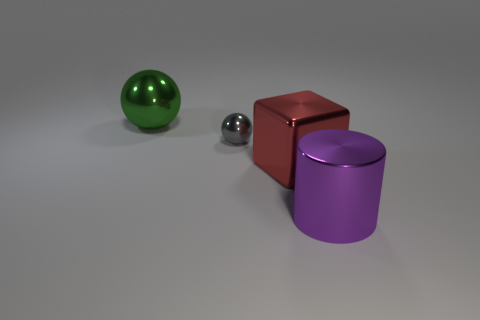Add 1 large cyan objects. How many objects exist? 5 Subtract all cubes. How many objects are left? 3 Add 2 metallic things. How many metallic things are left? 6 Add 1 small cyan spheres. How many small cyan spheres exist? 1 Subtract 0 green cylinders. How many objects are left? 4 Subtract all small gray balls. Subtract all blocks. How many objects are left? 2 